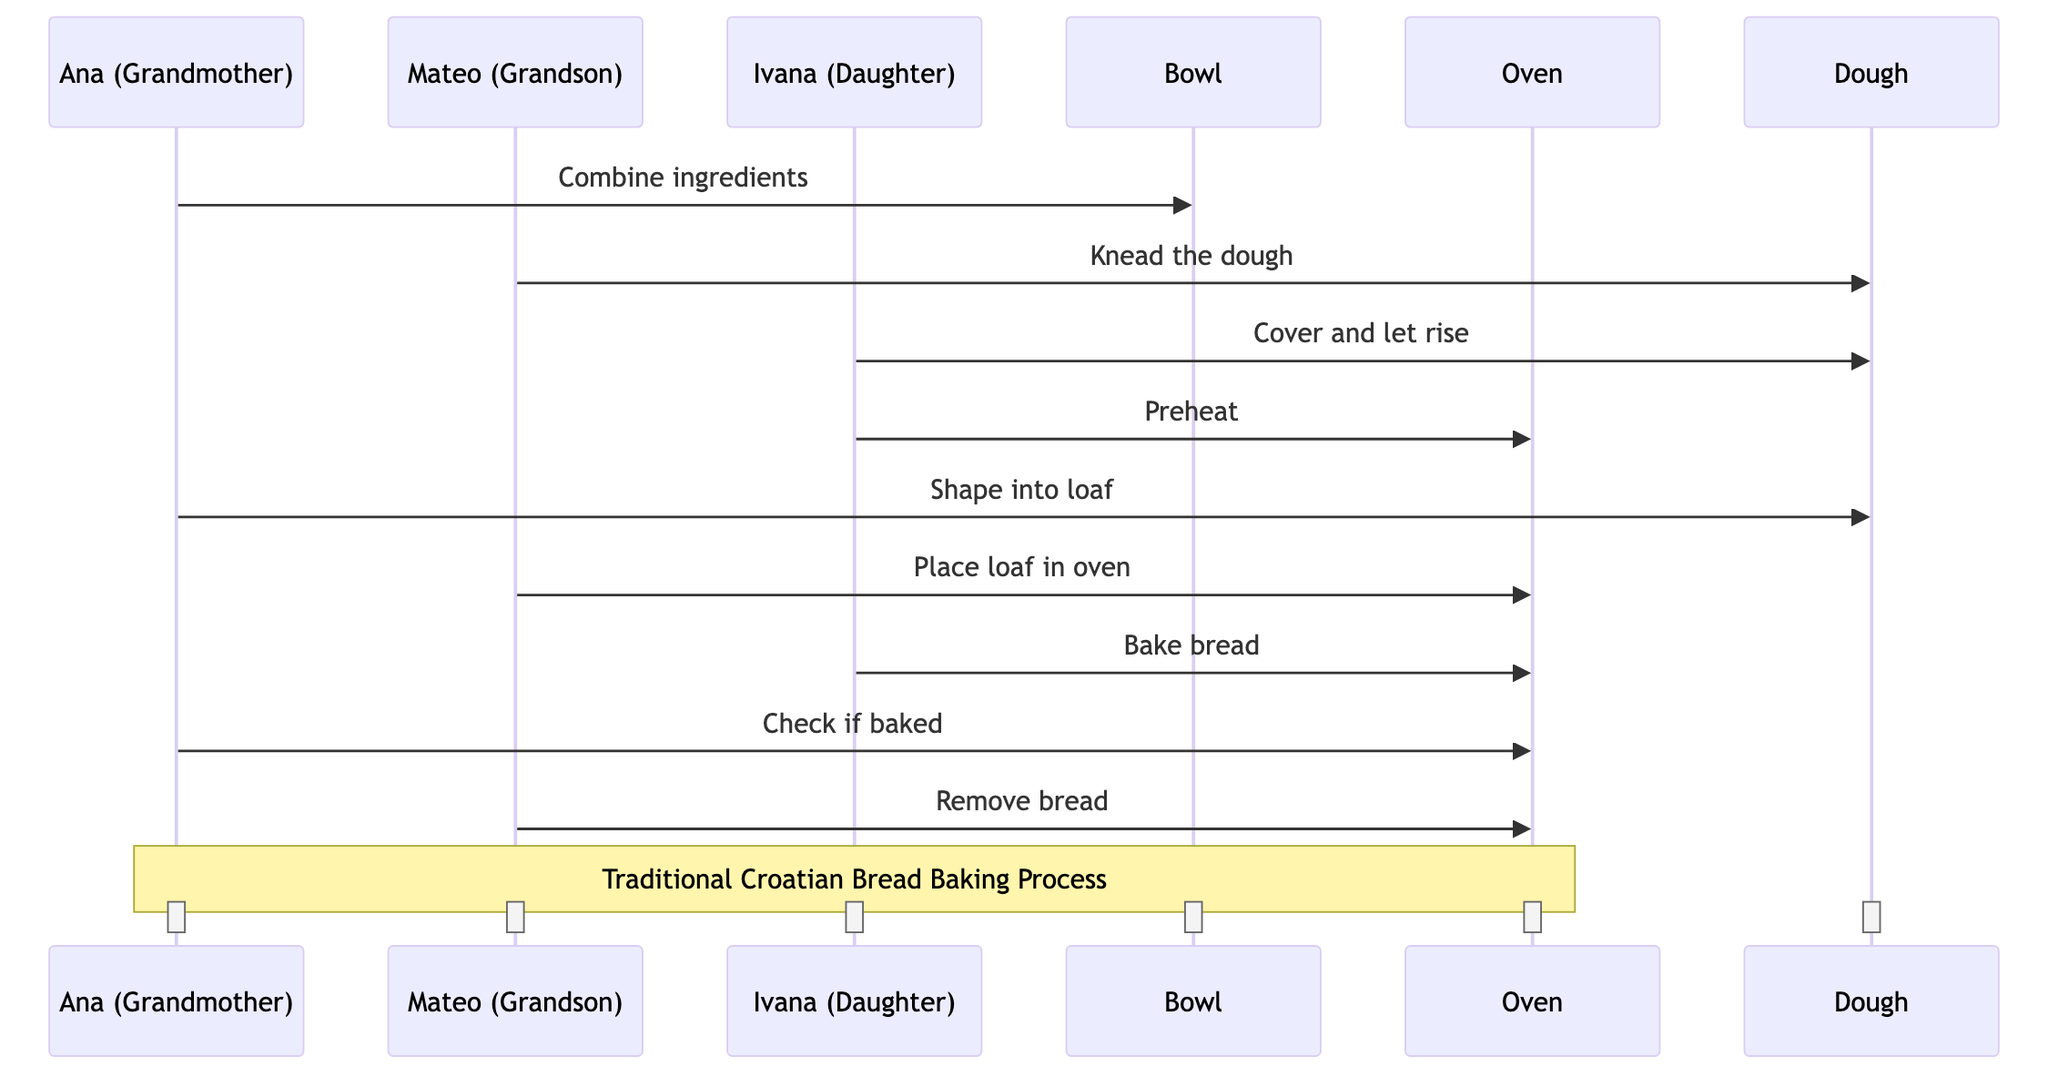What ingredients does Ana combine in the bowl? The diagram shows that Ana combines flour, water, yeast, sugar, and salt in the bowl during the first interaction.
Answer: Flour, water, yeast, sugar, and salt How many household members are involved in baking the bread? The diagram lists three household members: Ana, Mateo, and Ivana. Therefore, the answer is the total number of actors involved.
Answer: Three What action does Mateo perform after Ana combines the ingredients? Based on the sequence of actions in the diagram, Mateo kneads the dough immediately following Ana's action of combining the ingredients.
Answer: Knead the dough What is the final action taken before the bread is ready to be served? The diagram shows that after checking if the bread is baked, Mateo removes the bread from the oven as the final action before it is completed.
Answer: Remove bread Who covers the dough and lets it rise? According to the interactions in the diagram, Ivana is the one who covers the dough and lets it rise after Mateo kneads it.
Answer: Ivana Which kitchenware is used to shape the dough into a loaf? The diagram indicates that Ana shapes the dough into a loaf using the dough, therefore the kitchenware used is directly associated with the dough itself.
Answer: Dough What action does Ivana perform related to the oven? Ivana is responsible for preheating the oven early in the process and then also bakes the bread in the later sequence, making her actions crucial for oven operations.
Answer: Preheat and bake bread How many cooking steps involve the oven? The diagram outlines two actions related to the oven where Ivana preheats it and when she bakes the bread, plus one check by Ana and the removal by Mateo, which sums up the actions involving the oven.
Answer: Four 